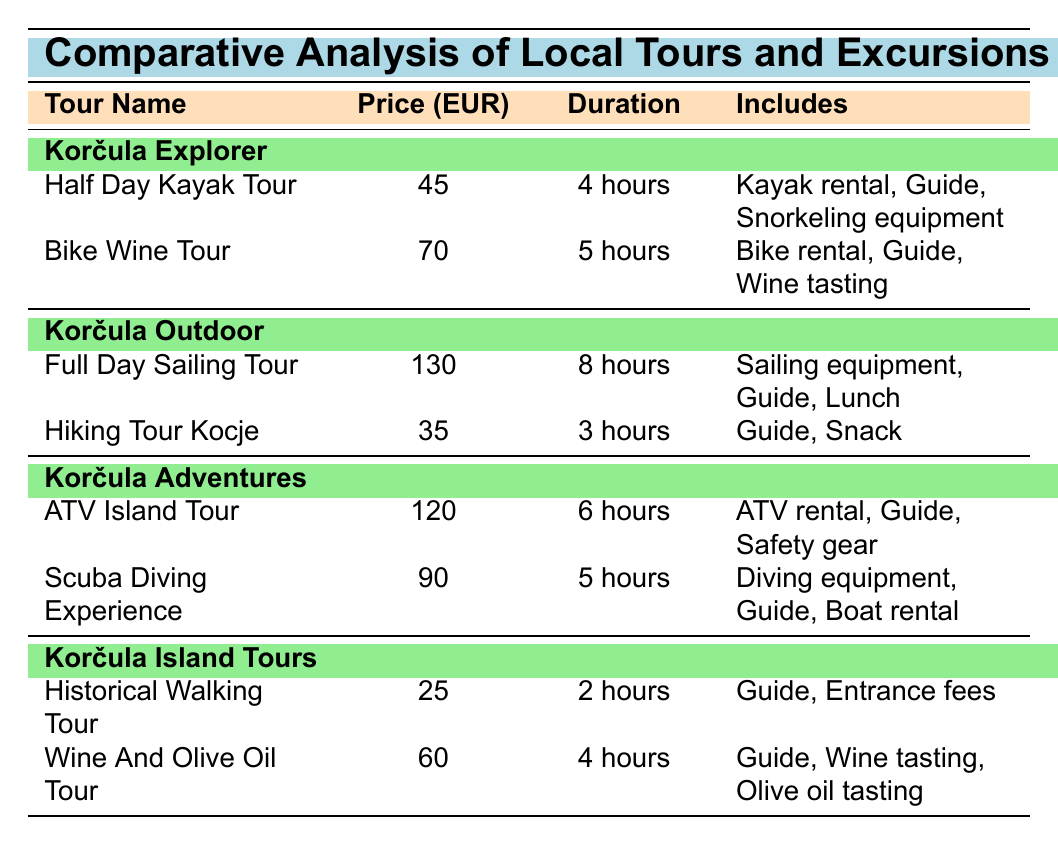What is the price of the Historical Walking Tour? The table lists the price of the Historical Walking Tour under the Korčula Island Tours section. The specific price provided is 25 EUR.
Answer: 25 EUR What is included in the Full Day Sailing Tour? The table clearly states that the Full Day Sailing Tour includes "Sailing equipment, Guide, Lunch" in the Includes column.
Answer: Sailing equipment, Guide, Lunch Which tour has the longest duration? By comparing the durations listed in the table, the Full Day Sailing Tour has the longest duration, which is 8 hours.
Answer: Full Day Sailing Tour What is the total price of the ATV Island Tour and the Scuba Diving Experience? First, extract the prices: ATV Island Tour is 120 EUR and Scuba Diving Experience is 90 EUR. Adding these together gives 120 + 90 = 210 EUR.
Answer: 210 EUR Is the Bike Wine Tour more expensive than the Half Day Kayak Tour? The price of the Bike Wine Tour is 70 EUR and the price of the Half Day Kayak Tour is 45 EUR. Since 70 is greater than 45, the answer is yes.
Answer: Yes What is the average price of the tours offered by Korčula Island Tours? The tours in Korčula Island Tours are Historical Walking Tour (25 EUR) and Wine And Olive Oil Tour (60 EUR). Sum the prices: 25 + 60 = 85. There are 2 tours, so the average is 85 / 2 = 42.5 EUR.
Answer: 42.5 EUR Is the duration of the Hiking Tour Kocje less than 4 hours? The Hiking Tour Kocje has a duration stated as 3 hours, which is indeed less than 4 hours. Therefore, the answer is yes.
Answer: Yes What is the price difference between the Wine And Olive Oil Tour and the Bike Wine Tour? The price of the Wine And Olive Oil Tour is 60 EUR and the price of the Bike Wine Tour is 70 EUR. The difference is calculated as 70 - 60 = 10 EUR.
Answer: 10 EUR Which tour includes both wine tasting and olive oil tasting? From the table, the Wine And Olive Oil Tour explicitly lists both "Wine tasting" and "Olive oil tasting" in the Includes column.
Answer: Wine And Olive Oil Tour 